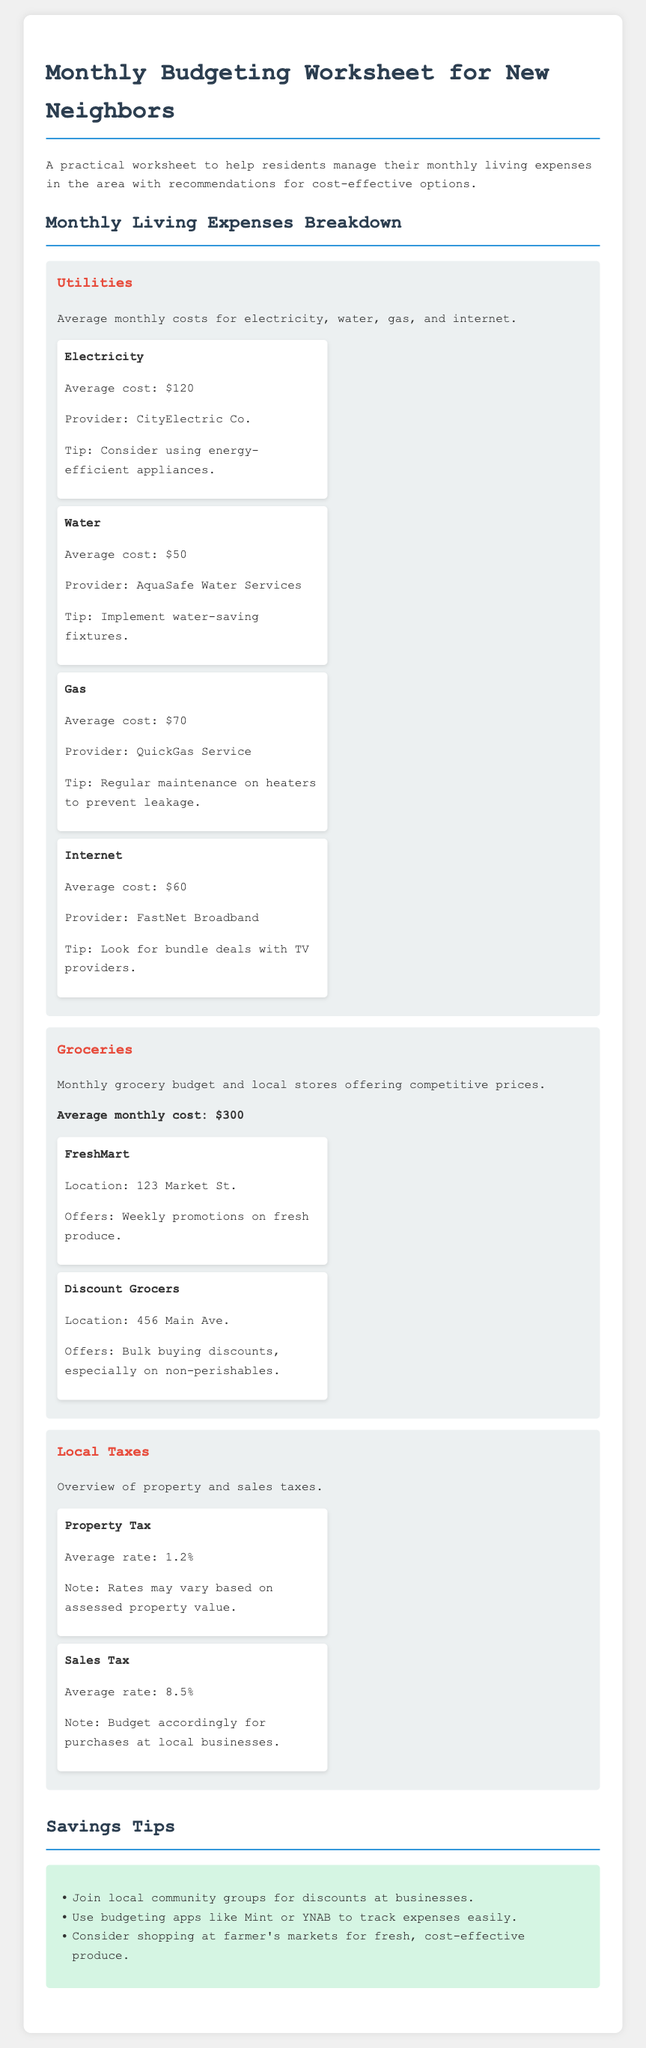What is the average cost of electricity? The average cost of electricity mentioned in the document is listed in the utilities section.
Answer: $120 Which store offers bulk buying discounts? The document provides information about local grocery stores and their offers, indicating one with bulk buying discounts.
Answer: Discount Grocers What is the average sales tax rate? The document details local taxes, including the specific average sales tax rate.
Answer: 8.5% How much is the average monthly grocery cost? The grocery section outlines the average monthly grocery budget.
Answer: $300 What is one tip for reducing electricity costs? The utilities section provides practical tips for saving costs, specifically for electricity.
Answer: Consider using energy-efficient appliances What is the average cost of gas? The utilities section describes the average cost of gas for budgeting purposes.
Answer: $70 Which water provider is listed in the document? The utilities details specify the provider for water services relevant to residents.
Answer: AquaSafe Water Services How can residents save on groceries? The budgeting worksheet lists local grocery options, highlighting recommendations for cost savings.
Answer: Join local community groups for discounts 